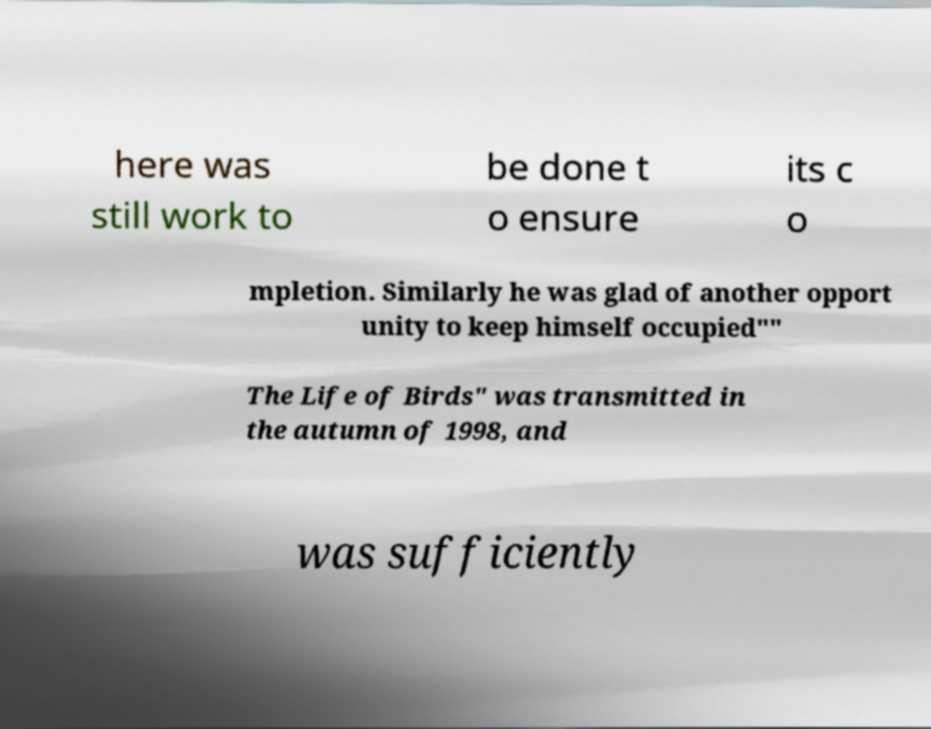For documentation purposes, I need the text within this image transcribed. Could you provide that? here was still work to be done t o ensure its c o mpletion. Similarly he was glad of another opport unity to keep himself occupied"" The Life of Birds" was transmitted in the autumn of 1998, and was sufficiently 